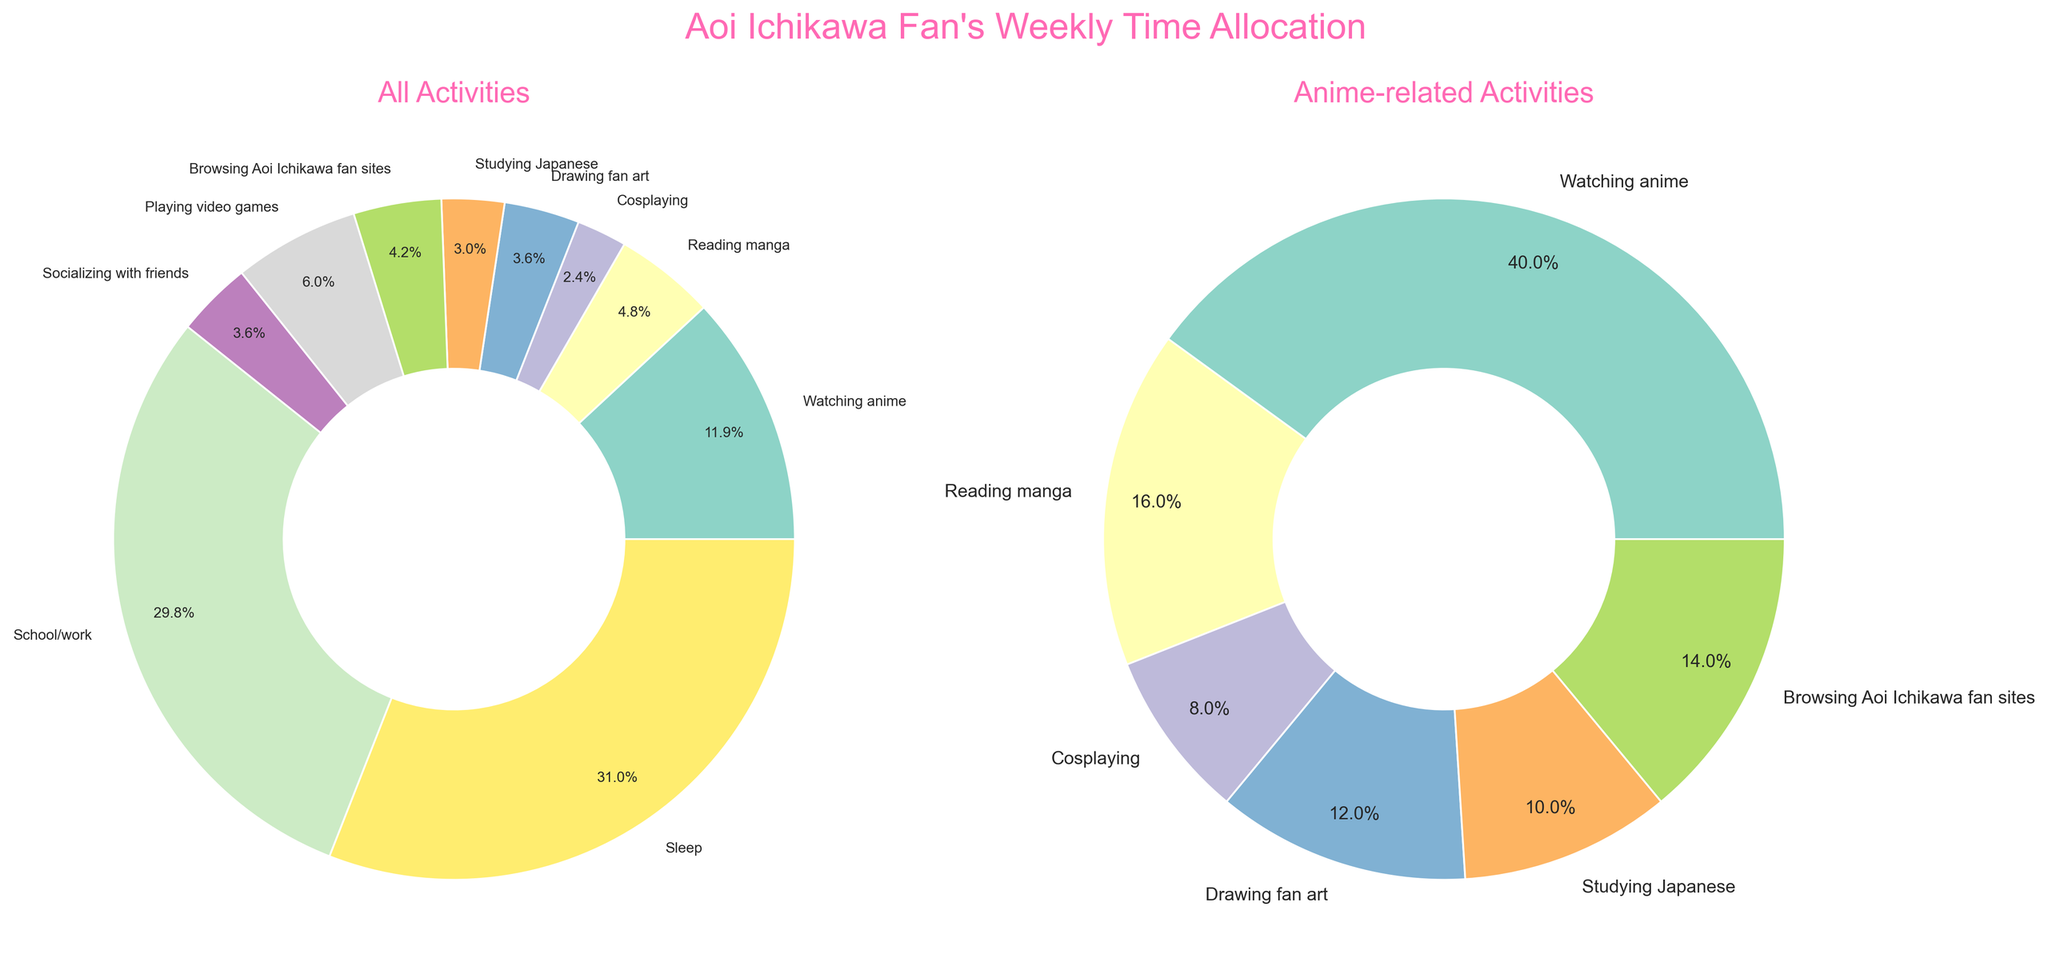How many hours per week are allocated to school/work? The pie chart labeled "All Activities" shows school/work with a specific percentage. Given the total hours for a week is 168, multiply the percentage of school/work by 168 to find the weekly hours.
Answer: 50 How many hours are allocated to watching anime in a typical week? The pie chart labeled "All Activities" explicitly shows a section for watching anime with a percentage. Considering the total of 168 hours in a week, refer directly to the number mentioned beside the anime section.
Answer: 20 Which activity takes up the most time in a typical week? Observing the "All Activities" pie chart, identify the largest segment. The activity with the highest percentage occupies the most hours.
Answer: Sleep How much more time is spent watching anime compared to cosplaying? From the "All Activities" pie chart, determine the hours for both watching anime and cosplaying. Subtract the hours for cosplaying from that of watching anime.
Answer: 16 What proportion of the week is spent on anime-related activities? Adding up the hours spent on anime-related activities from the specific anime-related pie chart (watching anime, reading manga, cosplaying, drawing fan art, studying Japanese, browsing Aoi Ichikawa fan sites), then divide the sum by the total weekly hours (168) and convert to percentage.
Answer: 30.4% How do the hours spent socializing with friends compare to those spent playing video games? Refer to the "All Activities" pie chart and identify the hours of both socializing and playing video games. Compare the two values to determine which is greater.
Answer: More time is spent playing video games Among the anime-related activities, which one takes up the least amount of time? Look at the "Anime-related Activities" pie chart to identify the smallest segment which represents the activity with the least hours.
Answer: Cosplaying What is the combined percentage of time spent on sleeping and school/work? Refer to the "All Activities" pie chart to find the percentages for sleeping and school/work. Sum these two percentages to get the combined percentage.
Answer: 60.7% Which non-anime activity takes the most time? In the "All Activities" pie chart, identify non-anime related segments and compare their sizes to find out the largest segment.
Answer: Sleep Between drawing fan art and studying Japanese, which one consumes more hours per week? Find the hours allocated to each of these activities from the "All Activities" pie chart. The larger value will indicate which activity takes more time.
Answer: Drawing fan art 